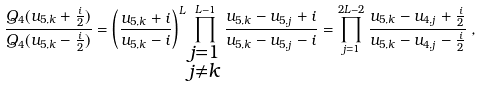<formula> <loc_0><loc_0><loc_500><loc_500>\frac { Q _ { 4 } ( u _ { 5 , k } + \frac { i } { 2 } ) } { Q _ { 4 } ( u _ { 5 , k } - \frac { i } { 2 } ) } = \left ( \frac { u _ { 5 , k } + i } { u _ { 5 , k } - i } \right ) ^ { L } \prod ^ { L - 1 } _ { \substack { j = 1 \\ j \neq k } } \frac { u _ { 5 , k } - u _ { 5 , j } + i } { u _ { 5 , k } - u _ { 5 , j } - i } = \prod ^ { 2 L - 2 } _ { j = 1 } \frac { u _ { 5 , k } - u _ { 4 , j } + \frac { i } { 2 } } { u _ { 5 , k } - u _ { 4 , j } - \frac { i } { 2 } } \, ,</formula> 